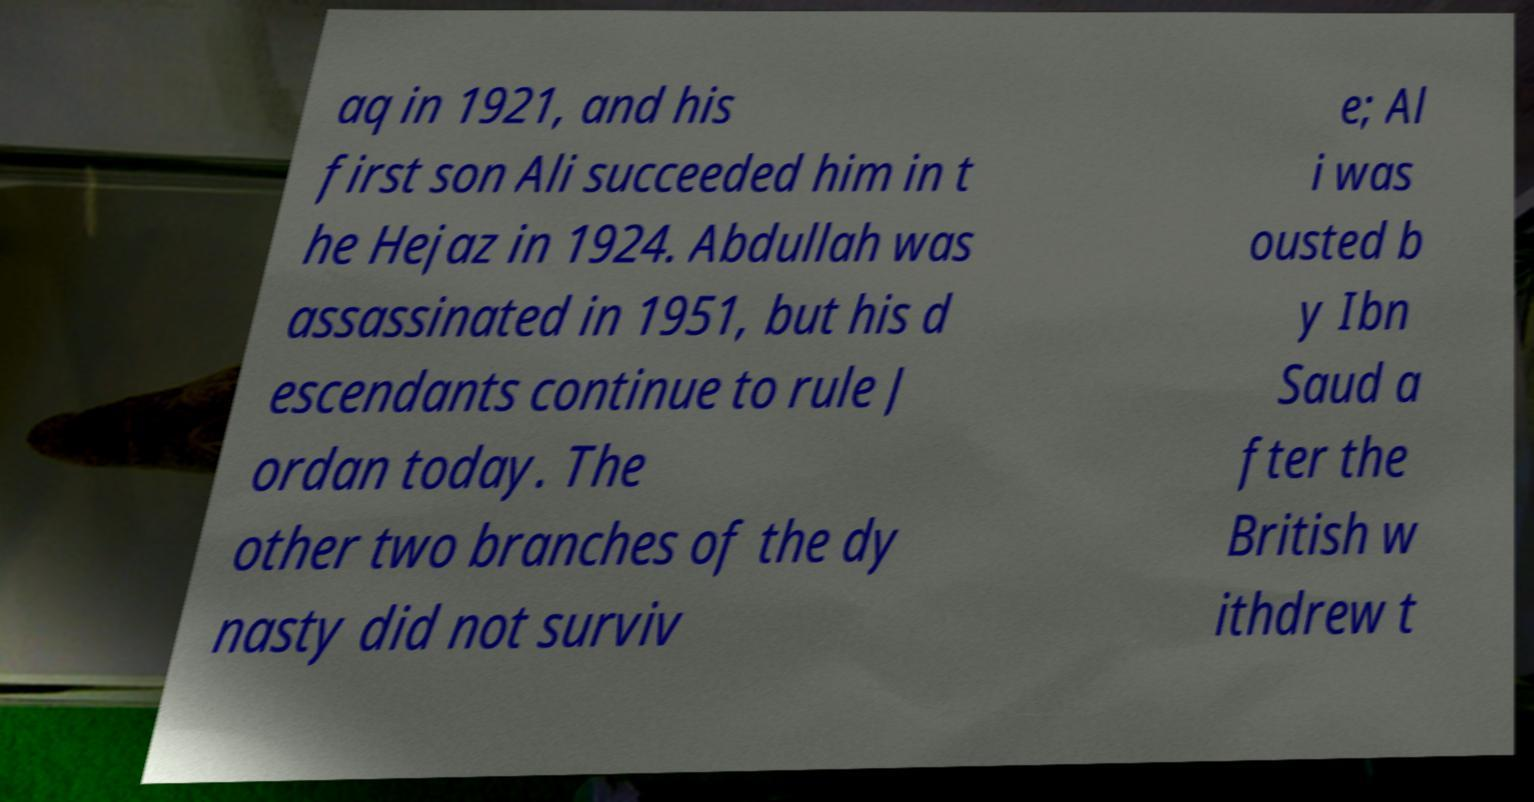Could you extract and type out the text from this image? aq in 1921, and his first son Ali succeeded him in t he Hejaz in 1924. Abdullah was assassinated in 1951, but his d escendants continue to rule J ordan today. The other two branches of the dy nasty did not surviv e; Al i was ousted b y Ibn Saud a fter the British w ithdrew t 